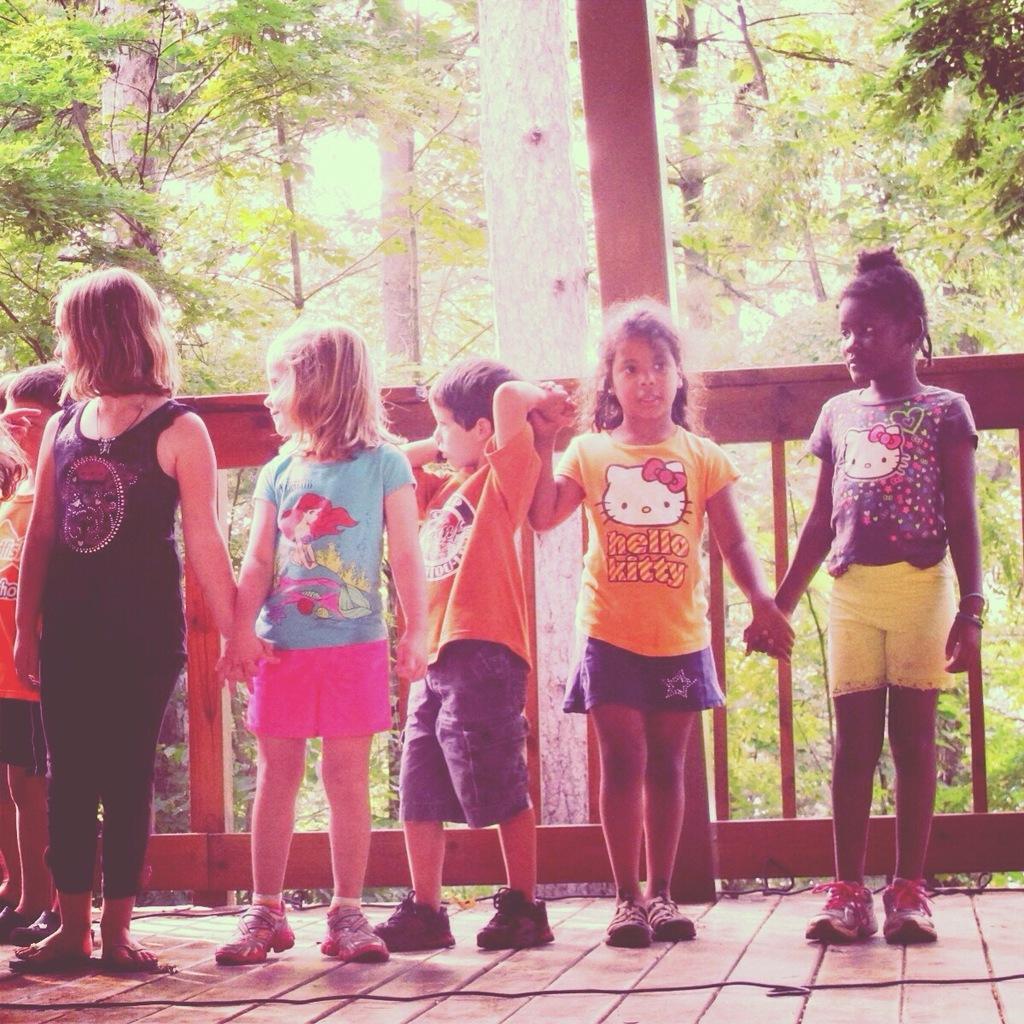In one or two sentences, can you explain what this image depicts? Here we can see few kids standing on the floor by holding their hands each other and there is a cable on the floor. In the background we can see fence,trees and sky. 